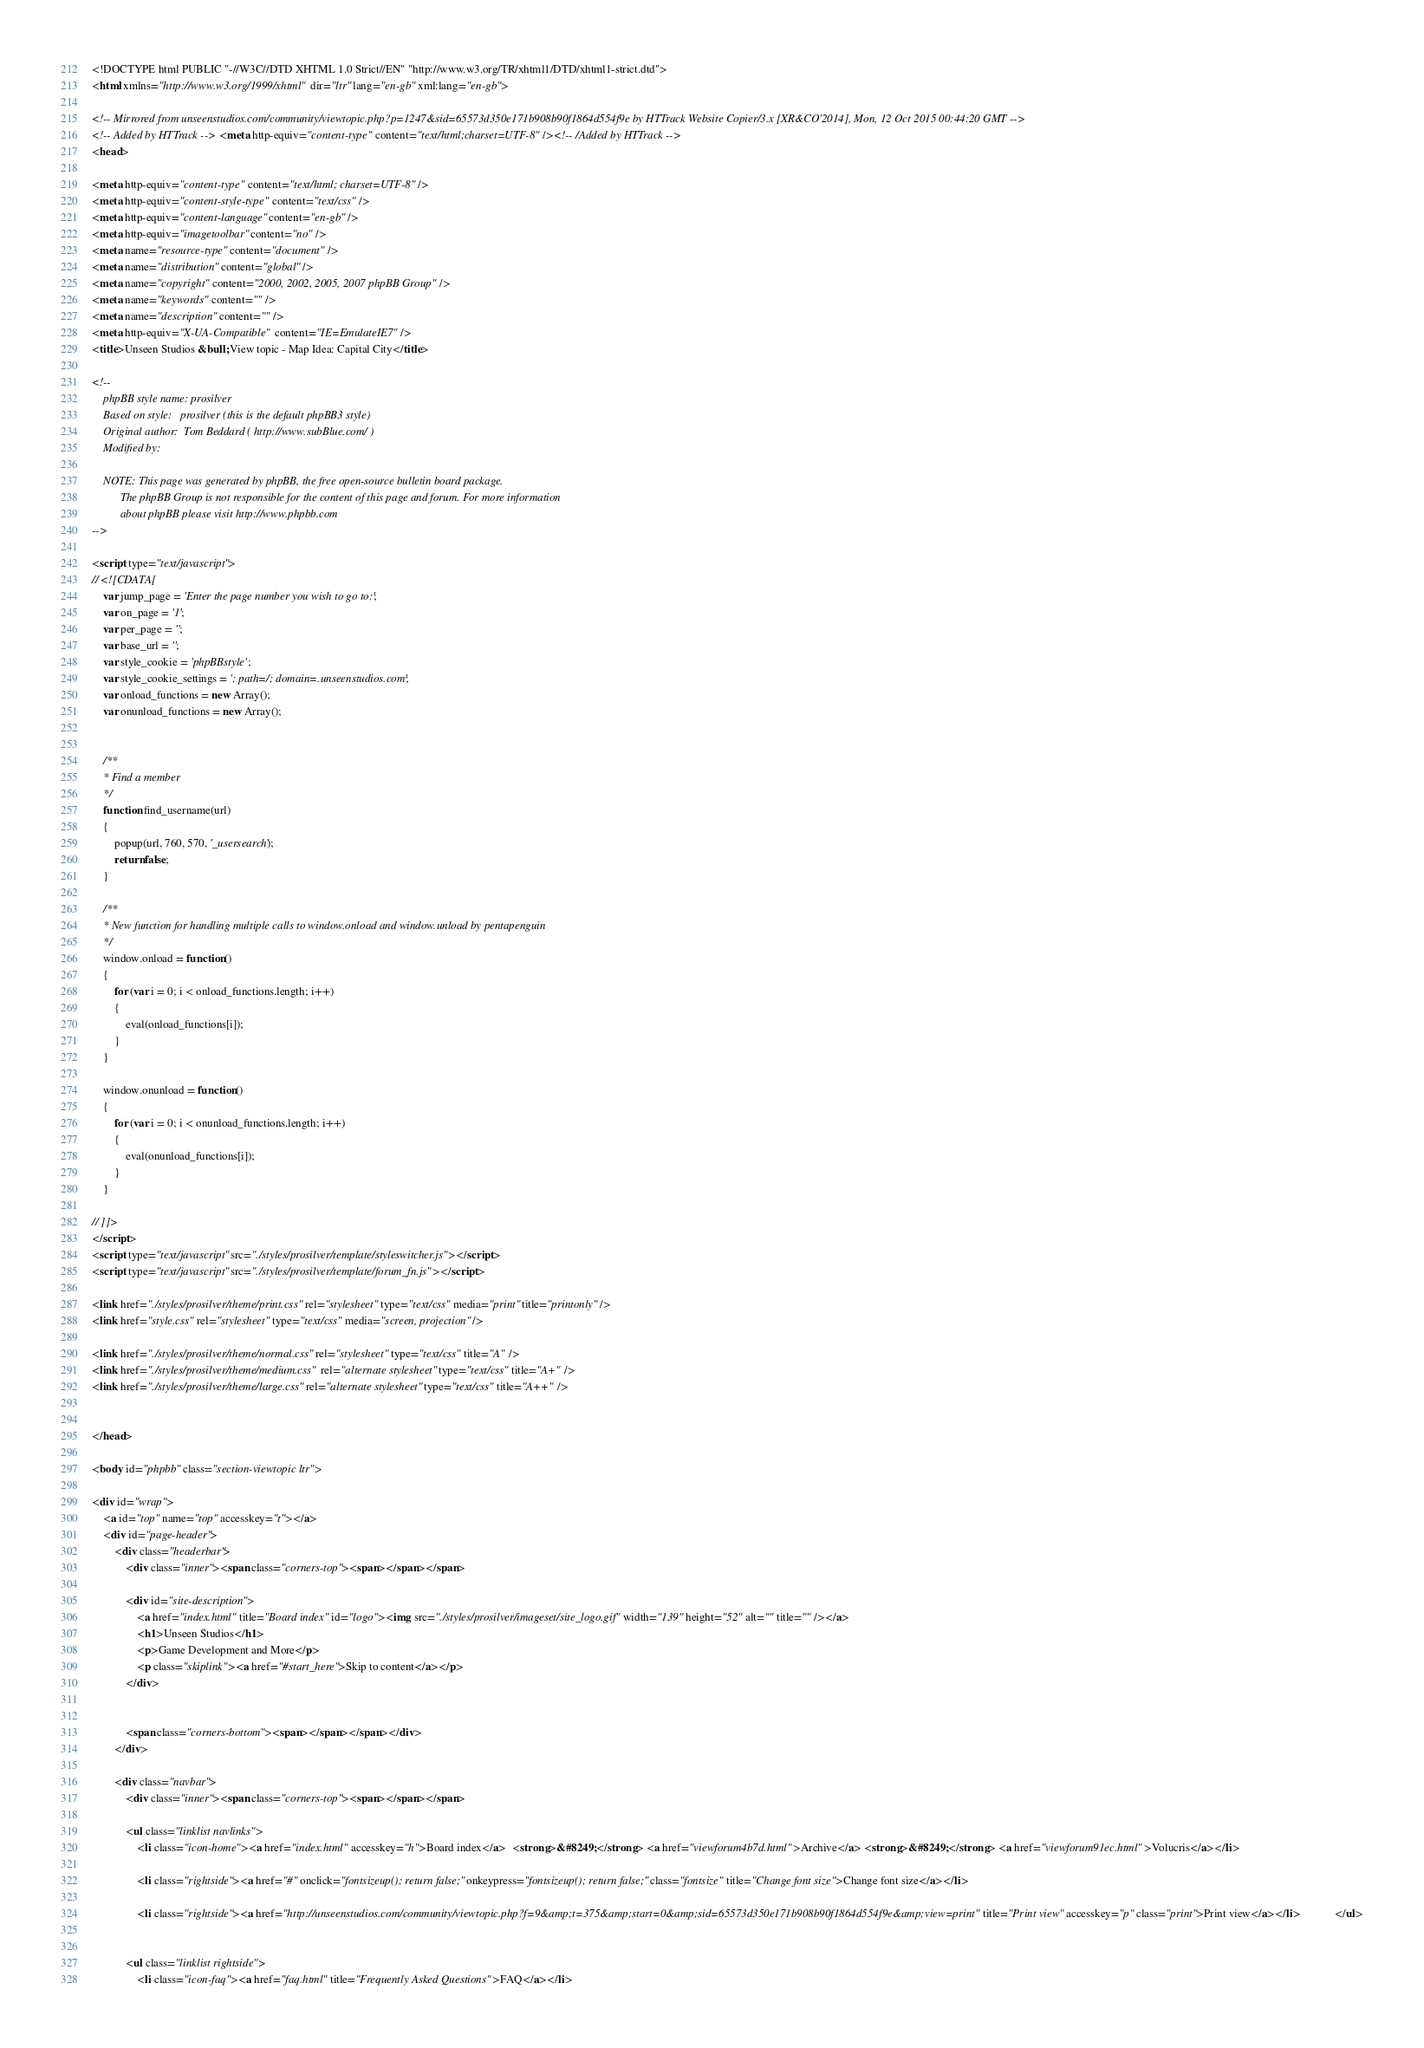Convert code to text. <code><loc_0><loc_0><loc_500><loc_500><_HTML_><!DOCTYPE html PUBLIC "-//W3C//DTD XHTML 1.0 Strict//EN" "http://www.w3.org/TR/xhtml1/DTD/xhtml1-strict.dtd">
<html xmlns="http://www.w3.org/1999/xhtml" dir="ltr" lang="en-gb" xml:lang="en-gb">

<!-- Mirrored from unseenstudios.com/community/viewtopic.php?p=1247&sid=65573d350e171b908b90f1864d554f9e by HTTrack Website Copier/3.x [XR&CO'2014], Mon, 12 Oct 2015 00:44:20 GMT -->
<!-- Added by HTTrack --><meta http-equiv="content-type" content="text/html;charset=UTF-8" /><!-- /Added by HTTrack -->
<head>

<meta http-equiv="content-type" content="text/html; charset=UTF-8" />
<meta http-equiv="content-style-type" content="text/css" />
<meta http-equiv="content-language" content="en-gb" />
<meta http-equiv="imagetoolbar" content="no" />
<meta name="resource-type" content="document" />
<meta name="distribution" content="global" />
<meta name="copyright" content="2000, 2002, 2005, 2007 phpBB Group" />
<meta name="keywords" content="" />
<meta name="description" content="" />
<meta http-equiv="X-UA-Compatible" content="IE=EmulateIE7" />
<title>Unseen Studios &bull; View topic - Map Idea: Capital City</title>

<!--
	phpBB style name: prosilver
	Based on style:   prosilver (this is the default phpBB3 style)
	Original author:  Tom Beddard ( http://www.subBlue.com/ )
	Modified by:      
	
	NOTE: This page was generated by phpBB, the free open-source bulletin board package.
	      The phpBB Group is not responsible for the content of this page and forum. For more information
	      about phpBB please visit http://www.phpbb.com
-->

<script type="text/javascript">
// <![CDATA[
	var jump_page = 'Enter the page number you wish to go to:';
	var on_page = '1';
	var per_page = '';
	var base_url = '';
	var style_cookie = 'phpBBstyle';
	var style_cookie_settings = '; path=/; domain=.unseenstudios.com';
	var onload_functions = new Array();
	var onunload_functions = new Array();

	
	/**
	* Find a member
	*/
	function find_username(url)
	{
		popup(url, 760, 570, '_usersearch');
		return false;
	}

	/**
	* New function for handling multiple calls to window.onload and window.unload by pentapenguin
	*/
	window.onload = function()
	{
		for (var i = 0; i < onload_functions.length; i++)
		{
			eval(onload_functions[i]);
		}
	}

	window.onunload = function()
	{
		for (var i = 0; i < onunload_functions.length; i++)
		{
			eval(onunload_functions[i]);
		}
	}

// ]]>
</script>
<script type="text/javascript" src="./styles/prosilver/template/styleswitcher.js"></script>
<script type="text/javascript" src="./styles/prosilver/template/forum_fn.js"></script>

<link href="./styles/prosilver/theme/print.css" rel="stylesheet" type="text/css" media="print" title="printonly" />
<link href="style.css" rel="stylesheet" type="text/css" media="screen, projection" />

<link href="./styles/prosilver/theme/normal.css" rel="stylesheet" type="text/css" title="A" />
<link href="./styles/prosilver/theme/medium.css" rel="alternate stylesheet" type="text/css" title="A+" />
<link href="./styles/prosilver/theme/large.css" rel="alternate stylesheet" type="text/css" title="A++" />


</head>

<body id="phpbb" class="section-viewtopic ltr">

<div id="wrap">
	<a id="top" name="top" accesskey="t"></a>
	<div id="page-header">
		<div class="headerbar">
			<div class="inner"><span class="corners-top"><span></span></span>

			<div id="site-description">
				<a href="index.html" title="Board index" id="logo"><img src="./styles/prosilver/imageset/site_logo.gif" width="139" height="52" alt="" title="" /></a>
				<h1>Unseen Studios</h1>
				<p>Game Development and More</p>
				<p class="skiplink"><a href="#start_here">Skip to content</a></p>
			</div>

		
			<span class="corners-bottom"><span></span></span></div>
		</div>

		<div class="navbar">
			<div class="inner"><span class="corners-top"><span></span></span>

			<ul class="linklist navlinks">
				<li class="icon-home"><a href="index.html" accesskey="h">Board index</a>  <strong>&#8249;</strong> <a href="viewforum4b7d.html">Archive</a> <strong>&#8249;</strong> <a href="viewforum91ec.html">Volucris</a></li>

				<li class="rightside"><a href="#" onclick="fontsizeup(); return false;" onkeypress="fontsizeup(); return false;" class="fontsize" title="Change font size">Change font size</a></li>

				<li class="rightside"><a href="http://unseenstudios.com/community/viewtopic.php?f=9&amp;t=375&amp;start=0&amp;sid=65573d350e171b908b90f1864d554f9e&amp;view=print" title="Print view" accesskey="p" class="print">Print view</a></li>			</ul>

			
			<ul class="linklist rightside">
				<li class="icon-faq"><a href="faq.html" title="Frequently Asked Questions">FAQ</a></li></code> 